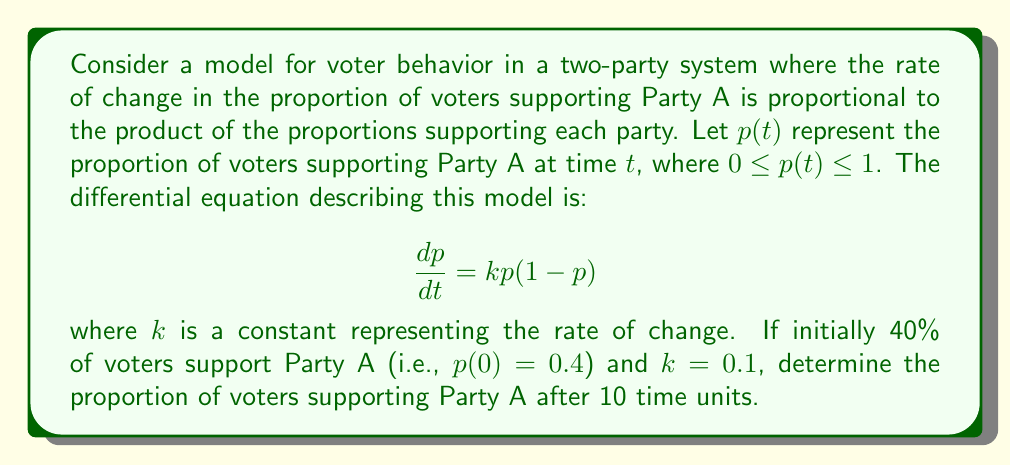Can you solve this math problem? To solve this problem, we need to use the logistic differential equation, which is a common model for population growth and can be applied to voter behavior patterns.

1) The given differential equation is:
   $$\frac{dp}{dt} = kp(1-p)$$

2) The solution to this equation is the logistic function:
   $$p(t) = \frac{1}{1 + (\frac{1}{p_0} - 1)e^{-kt}}$$
   where $p_0$ is the initial proportion at $t=0$.

3) We are given:
   - $p_0 = 0.4$ (initial proportion supporting Party A)
   - $k = 0.1$ (rate constant)
   - $t = 10$ (time units)

4) Substituting these values into the logistic function:
   $$p(10) = \frac{1}{1 + (\frac{1}{0.4} - 1)e^{-0.1(10)}}$$

5) Simplify:
   $$p(10) = \frac{1}{1 + (2.5 - 1)e^{-1}}$$
   $$p(10) = \frac{1}{1 + 1.5e^{-1}}$$

6) Calculate $e^{-1} \approx 0.3679$:
   $$p(10) = \frac{1}{1 + 1.5(0.3679)}$$
   $$p(10) = \frac{1}{1 + 0.5518}$$

7) Final calculation:
   $$p(10) = \frac{1}{1.5518} \approx 0.6444$$

Therefore, after 10 time units, approximately 64.44% of voters will support Party A.
Answer: $p(10) \approx 0.6444$ or 64.44% 